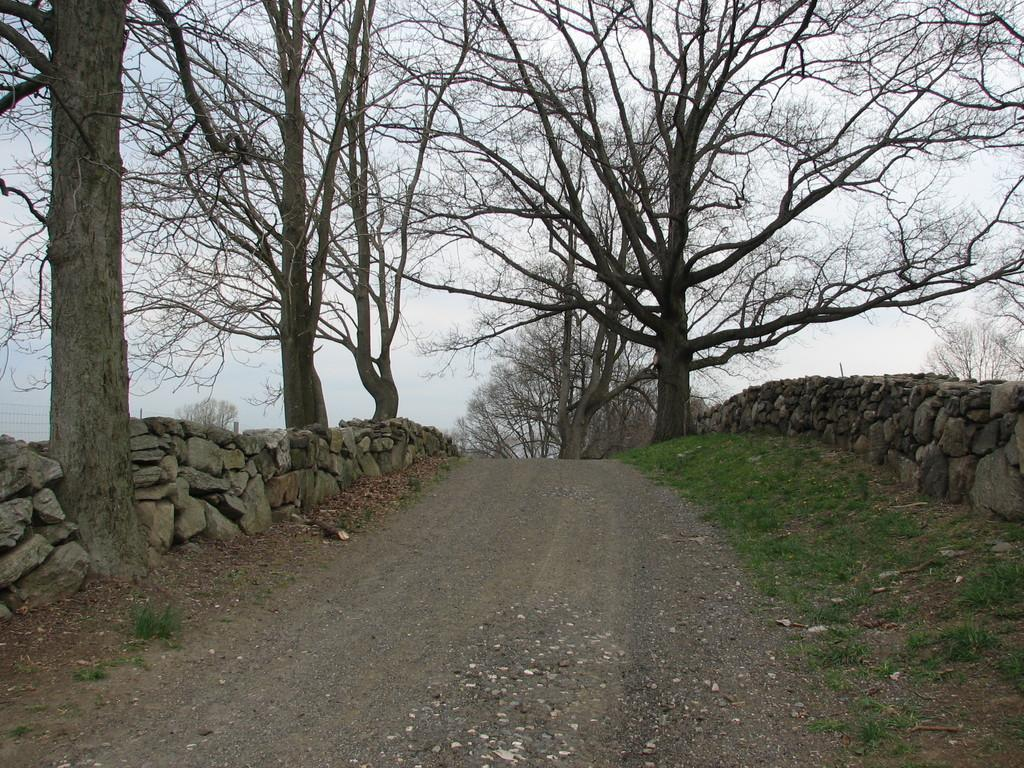What can be seen in the background of the image? There is a sky visible in the background of the image, along with bare trees. What is located on either side of the pathway in the image? There are stone walls on either side of the pathway, and grass and bare trees are also present on either side. What type of fiction is being read by the trees in the image? There are no trees reading fiction in the image, as trees do not have the ability to read. 